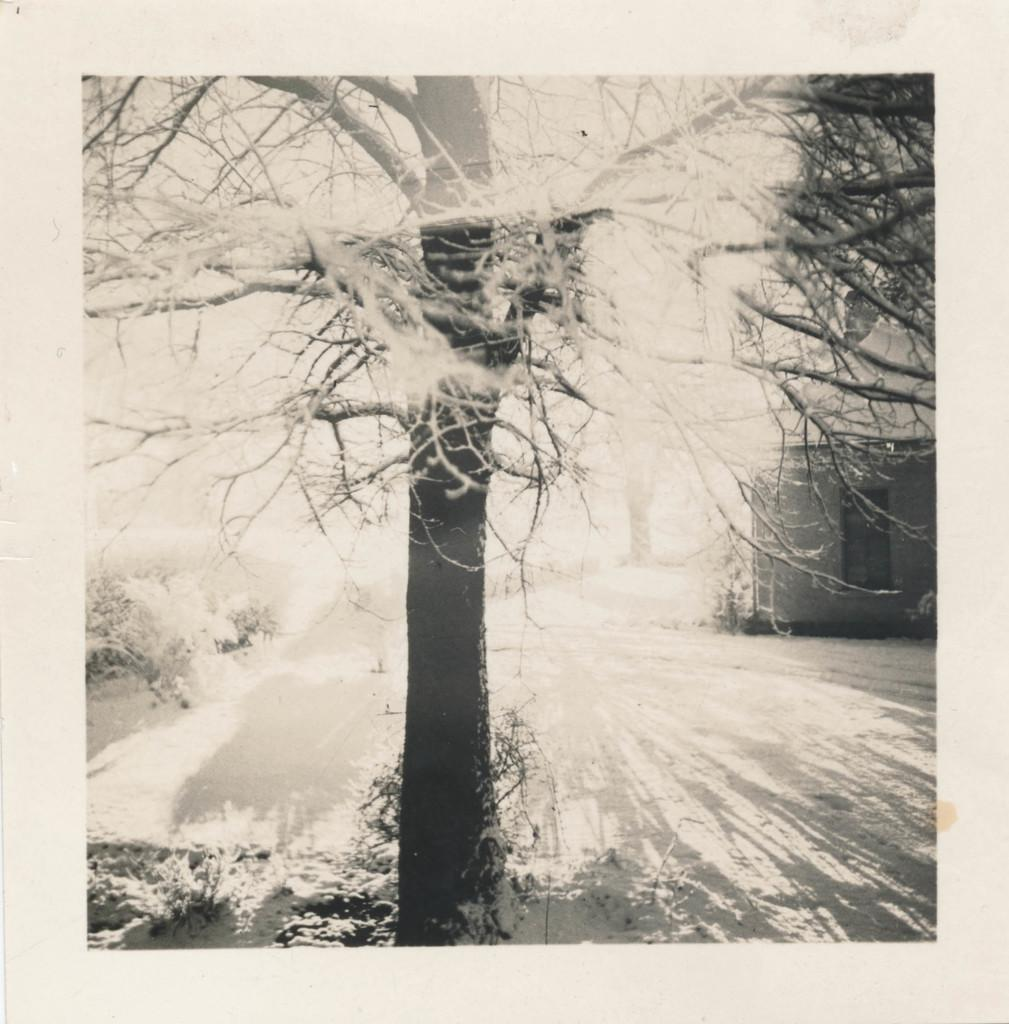What is depicted on the left side of the poster? There is a tree and plants on the left side of the poster. What is shown on the right side of the poster? There is a house on the right side of the poster. What can be observed as a result of the tree's presence in the image? The shadow of trees is visible on the ground. What type of honey is being harvested from the bushes in the image? There are no bushes or honey present in the image; it features a tree, plants, and a house. What religious symbols can be seen in the image? There are no religious symbols present in the image. 